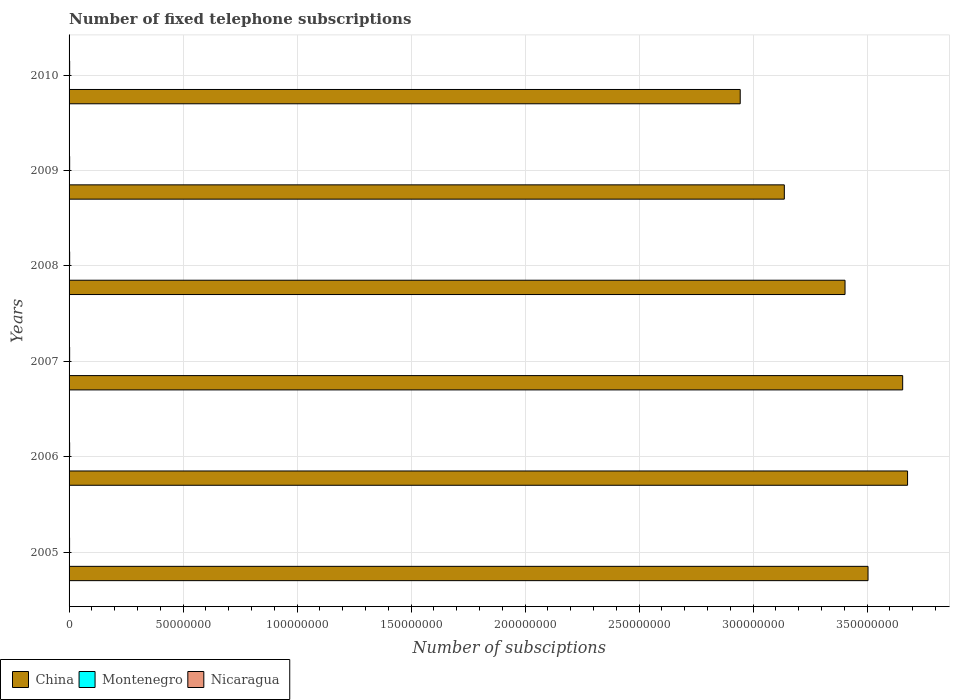How many groups of bars are there?
Ensure brevity in your answer.  6. Are the number of bars per tick equal to the number of legend labels?
Provide a succinct answer. Yes. In how many cases, is the number of bars for a given year not equal to the number of legend labels?
Make the answer very short. 0. What is the number of fixed telephone subscriptions in Montenegro in 2009?
Ensure brevity in your answer.  1.72e+05. Across all years, what is the maximum number of fixed telephone subscriptions in Montenegro?
Keep it short and to the point. 1.76e+05. Across all years, what is the minimum number of fixed telephone subscriptions in Montenegro?
Make the answer very short. 1.68e+05. In which year was the number of fixed telephone subscriptions in China minimum?
Offer a terse response. 2010. What is the total number of fixed telephone subscriptions in Montenegro in the graph?
Give a very brief answer. 1.03e+06. What is the difference between the number of fixed telephone subscriptions in Montenegro in 2007 and that in 2010?
Offer a very short reply. 5736. What is the difference between the number of fixed telephone subscriptions in Montenegro in 2010 and the number of fixed telephone subscriptions in China in 2007?
Give a very brief answer. -3.65e+08. What is the average number of fixed telephone subscriptions in Montenegro per year?
Keep it short and to the point. 1.72e+05. In the year 2008, what is the difference between the number of fixed telephone subscriptions in China and number of fixed telephone subscriptions in Montenegro?
Your response must be concise. 3.40e+08. In how many years, is the number of fixed telephone subscriptions in China greater than 10000000 ?
Provide a succinct answer. 6. What is the ratio of the number of fixed telephone subscriptions in China in 2005 to that in 2010?
Your answer should be very brief. 1.19. Is the number of fixed telephone subscriptions in Nicaragua in 2007 less than that in 2009?
Provide a short and direct response. Yes. What is the difference between the highest and the second highest number of fixed telephone subscriptions in Nicaragua?
Make the answer very short. 3639. What is the difference between the highest and the lowest number of fixed telephone subscriptions in Montenegro?
Give a very brief answer. 8056. What does the 2nd bar from the top in 2005 represents?
Make the answer very short. Montenegro. What does the 2nd bar from the bottom in 2010 represents?
Keep it short and to the point. Montenegro. How many bars are there?
Give a very brief answer. 18. What is the difference between two consecutive major ticks on the X-axis?
Your answer should be very brief. 5.00e+07. Are the values on the major ticks of X-axis written in scientific E-notation?
Your answer should be compact. No. Does the graph contain grids?
Keep it short and to the point. Yes. How many legend labels are there?
Your response must be concise. 3. How are the legend labels stacked?
Give a very brief answer. Horizontal. What is the title of the graph?
Provide a succinct answer. Number of fixed telephone subscriptions. Does "High income: OECD" appear as one of the legend labels in the graph?
Keep it short and to the point. No. What is the label or title of the X-axis?
Ensure brevity in your answer.  Number of subsciptions. What is the Number of subsciptions of China in 2005?
Give a very brief answer. 3.50e+08. What is the Number of subsciptions of Montenegro in 2005?
Ensure brevity in your answer.  1.71e+05. What is the Number of subsciptions in Nicaragua in 2005?
Make the answer very short. 2.21e+05. What is the Number of subsciptions of China in 2006?
Your answer should be very brief. 3.68e+08. What is the Number of subsciptions in Montenegro in 2006?
Make the answer very short. 1.68e+05. What is the Number of subsciptions in Nicaragua in 2006?
Your answer should be very brief. 2.48e+05. What is the Number of subsciptions in China in 2007?
Offer a terse response. 3.66e+08. What is the Number of subsciptions of Montenegro in 2007?
Ensure brevity in your answer.  1.76e+05. What is the Number of subsciptions of Nicaragua in 2007?
Offer a very short reply. 2.49e+05. What is the Number of subsciptions in China in 2008?
Your answer should be very brief. 3.40e+08. What is the Number of subsciptions of Montenegro in 2008?
Make the answer very short. 1.74e+05. What is the Number of subsciptions in Nicaragua in 2008?
Your answer should be very brief. 2.54e+05. What is the Number of subsciptions of China in 2009?
Ensure brevity in your answer.  3.14e+08. What is the Number of subsciptions in Montenegro in 2009?
Ensure brevity in your answer.  1.72e+05. What is the Number of subsciptions of Nicaragua in 2009?
Keep it short and to the point. 2.55e+05. What is the Number of subsciptions of China in 2010?
Provide a succinct answer. 2.94e+08. What is the Number of subsciptions of Montenegro in 2010?
Your answer should be very brief. 1.71e+05. What is the Number of subsciptions of Nicaragua in 2010?
Your answer should be compact. 2.58e+05. Across all years, what is the maximum Number of subsciptions of China?
Give a very brief answer. 3.68e+08. Across all years, what is the maximum Number of subsciptions in Montenegro?
Ensure brevity in your answer.  1.76e+05. Across all years, what is the maximum Number of subsciptions of Nicaragua?
Offer a terse response. 2.58e+05. Across all years, what is the minimum Number of subsciptions of China?
Make the answer very short. 2.94e+08. Across all years, what is the minimum Number of subsciptions of Montenegro?
Make the answer very short. 1.68e+05. Across all years, what is the minimum Number of subsciptions in Nicaragua?
Offer a very short reply. 2.21e+05. What is the total Number of subsciptions in China in the graph?
Make the answer very short. 2.03e+09. What is the total Number of subsciptions in Montenegro in the graph?
Make the answer very short. 1.03e+06. What is the total Number of subsciptions in Nicaragua in the graph?
Your answer should be very brief. 1.49e+06. What is the difference between the Number of subsciptions of China in 2005 and that in 2006?
Provide a succinct answer. -1.73e+07. What is the difference between the Number of subsciptions in Montenegro in 2005 and that in 2006?
Provide a short and direct response. 2700. What is the difference between the Number of subsciptions in Nicaragua in 2005 and that in 2006?
Provide a succinct answer. -2.70e+04. What is the difference between the Number of subsciptions in China in 2005 and that in 2007?
Your response must be concise. -1.52e+07. What is the difference between the Number of subsciptions of Montenegro in 2005 and that in 2007?
Offer a terse response. -5356. What is the difference between the Number of subsciptions in Nicaragua in 2005 and that in 2007?
Give a very brief answer. -2.81e+04. What is the difference between the Number of subsciptions of China in 2005 and that in 2008?
Provide a succinct answer. 1.01e+07. What is the difference between the Number of subsciptions of Montenegro in 2005 and that in 2008?
Provide a short and direct response. -3113. What is the difference between the Number of subsciptions in Nicaragua in 2005 and that in 2008?
Give a very brief answer. -3.36e+04. What is the difference between the Number of subsciptions of China in 2005 and that in 2009?
Your answer should be very brief. 3.67e+07. What is the difference between the Number of subsciptions of Montenegro in 2005 and that in 2009?
Make the answer very short. -816. What is the difference between the Number of subsciptions in Nicaragua in 2005 and that in 2009?
Provide a short and direct response. -3.38e+04. What is the difference between the Number of subsciptions in China in 2005 and that in 2010?
Offer a very short reply. 5.61e+07. What is the difference between the Number of subsciptions of Montenegro in 2005 and that in 2010?
Give a very brief answer. 380. What is the difference between the Number of subsciptions of Nicaragua in 2005 and that in 2010?
Offer a terse response. -3.75e+04. What is the difference between the Number of subsciptions of China in 2006 and that in 2007?
Ensure brevity in your answer.  2.15e+06. What is the difference between the Number of subsciptions in Montenegro in 2006 and that in 2007?
Make the answer very short. -8056. What is the difference between the Number of subsciptions of Nicaragua in 2006 and that in 2007?
Offer a very short reply. -1138. What is the difference between the Number of subsciptions in China in 2006 and that in 2008?
Provide a short and direct response. 2.74e+07. What is the difference between the Number of subsciptions in Montenegro in 2006 and that in 2008?
Give a very brief answer. -5813. What is the difference between the Number of subsciptions of Nicaragua in 2006 and that in 2008?
Offer a terse response. -6576. What is the difference between the Number of subsciptions of China in 2006 and that in 2009?
Ensure brevity in your answer.  5.41e+07. What is the difference between the Number of subsciptions in Montenegro in 2006 and that in 2009?
Provide a short and direct response. -3516. What is the difference between the Number of subsciptions of Nicaragua in 2006 and that in 2009?
Provide a succinct answer. -6824. What is the difference between the Number of subsciptions of China in 2006 and that in 2010?
Provide a succinct answer. 7.34e+07. What is the difference between the Number of subsciptions of Montenegro in 2006 and that in 2010?
Keep it short and to the point. -2320. What is the difference between the Number of subsciptions in Nicaragua in 2006 and that in 2010?
Make the answer very short. -1.05e+04. What is the difference between the Number of subsciptions in China in 2007 and that in 2008?
Make the answer very short. 2.53e+07. What is the difference between the Number of subsciptions in Montenegro in 2007 and that in 2008?
Offer a terse response. 2243. What is the difference between the Number of subsciptions in Nicaragua in 2007 and that in 2008?
Keep it short and to the point. -5438. What is the difference between the Number of subsciptions of China in 2007 and that in 2009?
Keep it short and to the point. 5.19e+07. What is the difference between the Number of subsciptions in Montenegro in 2007 and that in 2009?
Your answer should be compact. 4540. What is the difference between the Number of subsciptions of Nicaragua in 2007 and that in 2009?
Ensure brevity in your answer.  -5686. What is the difference between the Number of subsciptions of China in 2007 and that in 2010?
Provide a succinct answer. 7.13e+07. What is the difference between the Number of subsciptions in Montenegro in 2007 and that in 2010?
Your answer should be very brief. 5736. What is the difference between the Number of subsciptions in Nicaragua in 2007 and that in 2010?
Your answer should be compact. -9325. What is the difference between the Number of subsciptions in China in 2008 and that in 2009?
Offer a very short reply. 2.66e+07. What is the difference between the Number of subsciptions in Montenegro in 2008 and that in 2009?
Give a very brief answer. 2297. What is the difference between the Number of subsciptions in Nicaragua in 2008 and that in 2009?
Give a very brief answer. -248. What is the difference between the Number of subsciptions in China in 2008 and that in 2010?
Make the answer very short. 4.60e+07. What is the difference between the Number of subsciptions of Montenegro in 2008 and that in 2010?
Offer a terse response. 3493. What is the difference between the Number of subsciptions of Nicaragua in 2008 and that in 2010?
Offer a terse response. -3887. What is the difference between the Number of subsciptions of China in 2009 and that in 2010?
Your response must be concise. 1.93e+07. What is the difference between the Number of subsciptions of Montenegro in 2009 and that in 2010?
Your answer should be compact. 1196. What is the difference between the Number of subsciptions in Nicaragua in 2009 and that in 2010?
Ensure brevity in your answer.  -3639. What is the difference between the Number of subsciptions of China in 2005 and the Number of subsciptions of Montenegro in 2006?
Make the answer very short. 3.50e+08. What is the difference between the Number of subsciptions in China in 2005 and the Number of subsciptions in Nicaragua in 2006?
Make the answer very short. 3.50e+08. What is the difference between the Number of subsciptions in Montenegro in 2005 and the Number of subsciptions in Nicaragua in 2006?
Make the answer very short. -7.69e+04. What is the difference between the Number of subsciptions in China in 2005 and the Number of subsciptions in Montenegro in 2007?
Provide a short and direct response. 3.50e+08. What is the difference between the Number of subsciptions of China in 2005 and the Number of subsciptions of Nicaragua in 2007?
Your answer should be very brief. 3.50e+08. What is the difference between the Number of subsciptions in Montenegro in 2005 and the Number of subsciptions in Nicaragua in 2007?
Provide a short and direct response. -7.81e+04. What is the difference between the Number of subsciptions in China in 2005 and the Number of subsciptions in Montenegro in 2008?
Your answer should be compact. 3.50e+08. What is the difference between the Number of subsciptions in China in 2005 and the Number of subsciptions in Nicaragua in 2008?
Provide a short and direct response. 3.50e+08. What is the difference between the Number of subsciptions in Montenegro in 2005 and the Number of subsciptions in Nicaragua in 2008?
Make the answer very short. -8.35e+04. What is the difference between the Number of subsciptions of China in 2005 and the Number of subsciptions of Montenegro in 2009?
Offer a terse response. 3.50e+08. What is the difference between the Number of subsciptions of China in 2005 and the Number of subsciptions of Nicaragua in 2009?
Offer a terse response. 3.50e+08. What is the difference between the Number of subsciptions of Montenegro in 2005 and the Number of subsciptions of Nicaragua in 2009?
Make the answer very short. -8.38e+04. What is the difference between the Number of subsciptions in China in 2005 and the Number of subsciptions in Montenegro in 2010?
Ensure brevity in your answer.  3.50e+08. What is the difference between the Number of subsciptions in China in 2005 and the Number of subsciptions in Nicaragua in 2010?
Provide a succinct answer. 3.50e+08. What is the difference between the Number of subsciptions of Montenegro in 2005 and the Number of subsciptions of Nicaragua in 2010?
Make the answer very short. -8.74e+04. What is the difference between the Number of subsciptions of China in 2006 and the Number of subsciptions of Montenegro in 2007?
Ensure brevity in your answer.  3.68e+08. What is the difference between the Number of subsciptions of China in 2006 and the Number of subsciptions of Nicaragua in 2007?
Keep it short and to the point. 3.68e+08. What is the difference between the Number of subsciptions of Montenegro in 2006 and the Number of subsciptions of Nicaragua in 2007?
Your answer should be compact. -8.08e+04. What is the difference between the Number of subsciptions of China in 2006 and the Number of subsciptions of Montenegro in 2008?
Keep it short and to the point. 3.68e+08. What is the difference between the Number of subsciptions of China in 2006 and the Number of subsciptions of Nicaragua in 2008?
Ensure brevity in your answer.  3.68e+08. What is the difference between the Number of subsciptions in Montenegro in 2006 and the Number of subsciptions in Nicaragua in 2008?
Ensure brevity in your answer.  -8.62e+04. What is the difference between the Number of subsciptions of China in 2006 and the Number of subsciptions of Montenegro in 2009?
Give a very brief answer. 3.68e+08. What is the difference between the Number of subsciptions of China in 2006 and the Number of subsciptions of Nicaragua in 2009?
Offer a very short reply. 3.68e+08. What is the difference between the Number of subsciptions in Montenegro in 2006 and the Number of subsciptions in Nicaragua in 2009?
Your answer should be compact. -8.65e+04. What is the difference between the Number of subsciptions in China in 2006 and the Number of subsciptions in Montenegro in 2010?
Ensure brevity in your answer.  3.68e+08. What is the difference between the Number of subsciptions of China in 2006 and the Number of subsciptions of Nicaragua in 2010?
Keep it short and to the point. 3.68e+08. What is the difference between the Number of subsciptions of Montenegro in 2006 and the Number of subsciptions of Nicaragua in 2010?
Keep it short and to the point. -9.01e+04. What is the difference between the Number of subsciptions of China in 2007 and the Number of subsciptions of Montenegro in 2008?
Keep it short and to the point. 3.65e+08. What is the difference between the Number of subsciptions of China in 2007 and the Number of subsciptions of Nicaragua in 2008?
Give a very brief answer. 3.65e+08. What is the difference between the Number of subsciptions in Montenegro in 2007 and the Number of subsciptions in Nicaragua in 2008?
Your response must be concise. -7.81e+04. What is the difference between the Number of subsciptions in China in 2007 and the Number of subsciptions in Montenegro in 2009?
Offer a very short reply. 3.65e+08. What is the difference between the Number of subsciptions in China in 2007 and the Number of subsciptions in Nicaragua in 2009?
Offer a very short reply. 3.65e+08. What is the difference between the Number of subsciptions of Montenegro in 2007 and the Number of subsciptions of Nicaragua in 2009?
Keep it short and to the point. -7.84e+04. What is the difference between the Number of subsciptions in China in 2007 and the Number of subsciptions in Montenegro in 2010?
Offer a terse response. 3.65e+08. What is the difference between the Number of subsciptions of China in 2007 and the Number of subsciptions of Nicaragua in 2010?
Keep it short and to the point. 3.65e+08. What is the difference between the Number of subsciptions in Montenegro in 2007 and the Number of subsciptions in Nicaragua in 2010?
Offer a very short reply. -8.20e+04. What is the difference between the Number of subsciptions of China in 2008 and the Number of subsciptions of Montenegro in 2009?
Provide a short and direct response. 3.40e+08. What is the difference between the Number of subsciptions in China in 2008 and the Number of subsciptions in Nicaragua in 2009?
Your answer should be very brief. 3.40e+08. What is the difference between the Number of subsciptions of Montenegro in 2008 and the Number of subsciptions of Nicaragua in 2009?
Your response must be concise. -8.06e+04. What is the difference between the Number of subsciptions in China in 2008 and the Number of subsciptions in Montenegro in 2010?
Ensure brevity in your answer.  3.40e+08. What is the difference between the Number of subsciptions in China in 2008 and the Number of subsciptions in Nicaragua in 2010?
Offer a very short reply. 3.40e+08. What is the difference between the Number of subsciptions in Montenegro in 2008 and the Number of subsciptions in Nicaragua in 2010?
Offer a very short reply. -8.43e+04. What is the difference between the Number of subsciptions of China in 2009 and the Number of subsciptions of Montenegro in 2010?
Your response must be concise. 3.14e+08. What is the difference between the Number of subsciptions in China in 2009 and the Number of subsciptions in Nicaragua in 2010?
Keep it short and to the point. 3.13e+08. What is the difference between the Number of subsciptions in Montenegro in 2009 and the Number of subsciptions in Nicaragua in 2010?
Your response must be concise. -8.66e+04. What is the average Number of subsciptions in China per year?
Offer a very short reply. 3.39e+08. What is the average Number of subsciptions in Montenegro per year?
Provide a succinct answer. 1.72e+05. What is the average Number of subsciptions in Nicaragua per year?
Ensure brevity in your answer.  2.48e+05. In the year 2005, what is the difference between the Number of subsciptions of China and Number of subsciptions of Montenegro?
Give a very brief answer. 3.50e+08. In the year 2005, what is the difference between the Number of subsciptions of China and Number of subsciptions of Nicaragua?
Provide a succinct answer. 3.50e+08. In the year 2005, what is the difference between the Number of subsciptions of Montenegro and Number of subsciptions of Nicaragua?
Your answer should be very brief. -4.99e+04. In the year 2006, what is the difference between the Number of subsciptions in China and Number of subsciptions in Montenegro?
Ensure brevity in your answer.  3.68e+08. In the year 2006, what is the difference between the Number of subsciptions in China and Number of subsciptions in Nicaragua?
Ensure brevity in your answer.  3.68e+08. In the year 2006, what is the difference between the Number of subsciptions of Montenegro and Number of subsciptions of Nicaragua?
Your answer should be very brief. -7.96e+04. In the year 2007, what is the difference between the Number of subsciptions in China and Number of subsciptions in Montenegro?
Your answer should be very brief. 3.65e+08. In the year 2007, what is the difference between the Number of subsciptions of China and Number of subsciptions of Nicaragua?
Give a very brief answer. 3.65e+08. In the year 2007, what is the difference between the Number of subsciptions of Montenegro and Number of subsciptions of Nicaragua?
Offer a terse response. -7.27e+04. In the year 2008, what is the difference between the Number of subsciptions in China and Number of subsciptions in Montenegro?
Offer a very short reply. 3.40e+08. In the year 2008, what is the difference between the Number of subsciptions in China and Number of subsciptions in Nicaragua?
Your answer should be very brief. 3.40e+08. In the year 2008, what is the difference between the Number of subsciptions of Montenegro and Number of subsciptions of Nicaragua?
Give a very brief answer. -8.04e+04. In the year 2009, what is the difference between the Number of subsciptions of China and Number of subsciptions of Montenegro?
Provide a succinct answer. 3.14e+08. In the year 2009, what is the difference between the Number of subsciptions of China and Number of subsciptions of Nicaragua?
Your response must be concise. 3.13e+08. In the year 2009, what is the difference between the Number of subsciptions of Montenegro and Number of subsciptions of Nicaragua?
Your answer should be compact. -8.29e+04. In the year 2010, what is the difference between the Number of subsciptions of China and Number of subsciptions of Montenegro?
Your response must be concise. 2.94e+08. In the year 2010, what is the difference between the Number of subsciptions of China and Number of subsciptions of Nicaragua?
Your response must be concise. 2.94e+08. In the year 2010, what is the difference between the Number of subsciptions of Montenegro and Number of subsciptions of Nicaragua?
Ensure brevity in your answer.  -8.78e+04. What is the ratio of the Number of subsciptions of China in 2005 to that in 2006?
Keep it short and to the point. 0.95. What is the ratio of the Number of subsciptions of Nicaragua in 2005 to that in 2006?
Provide a succinct answer. 0.89. What is the ratio of the Number of subsciptions in China in 2005 to that in 2007?
Provide a short and direct response. 0.96. What is the ratio of the Number of subsciptions of Montenegro in 2005 to that in 2007?
Give a very brief answer. 0.97. What is the ratio of the Number of subsciptions in Nicaragua in 2005 to that in 2007?
Provide a succinct answer. 0.89. What is the ratio of the Number of subsciptions of China in 2005 to that in 2008?
Offer a terse response. 1.03. What is the ratio of the Number of subsciptions of Montenegro in 2005 to that in 2008?
Keep it short and to the point. 0.98. What is the ratio of the Number of subsciptions of Nicaragua in 2005 to that in 2008?
Your answer should be compact. 0.87. What is the ratio of the Number of subsciptions in China in 2005 to that in 2009?
Your response must be concise. 1.12. What is the ratio of the Number of subsciptions of Nicaragua in 2005 to that in 2009?
Give a very brief answer. 0.87. What is the ratio of the Number of subsciptions in China in 2005 to that in 2010?
Offer a very short reply. 1.19. What is the ratio of the Number of subsciptions in Nicaragua in 2005 to that in 2010?
Ensure brevity in your answer.  0.85. What is the ratio of the Number of subsciptions of China in 2006 to that in 2007?
Your answer should be compact. 1.01. What is the ratio of the Number of subsciptions of Montenegro in 2006 to that in 2007?
Offer a terse response. 0.95. What is the ratio of the Number of subsciptions of China in 2006 to that in 2008?
Your answer should be compact. 1.08. What is the ratio of the Number of subsciptions in Montenegro in 2006 to that in 2008?
Your response must be concise. 0.97. What is the ratio of the Number of subsciptions in Nicaragua in 2006 to that in 2008?
Your answer should be very brief. 0.97. What is the ratio of the Number of subsciptions of China in 2006 to that in 2009?
Provide a short and direct response. 1.17. What is the ratio of the Number of subsciptions of Montenegro in 2006 to that in 2009?
Provide a succinct answer. 0.98. What is the ratio of the Number of subsciptions of Nicaragua in 2006 to that in 2009?
Provide a succinct answer. 0.97. What is the ratio of the Number of subsciptions in China in 2006 to that in 2010?
Your response must be concise. 1.25. What is the ratio of the Number of subsciptions in Montenegro in 2006 to that in 2010?
Your response must be concise. 0.99. What is the ratio of the Number of subsciptions of Nicaragua in 2006 to that in 2010?
Give a very brief answer. 0.96. What is the ratio of the Number of subsciptions in China in 2007 to that in 2008?
Ensure brevity in your answer.  1.07. What is the ratio of the Number of subsciptions in Montenegro in 2007 to that in 2008?
Provide a succinct answer. 1.01. What is the ratio of the Number of subsciptions in Nicaragua in 2007 to that in 2008?
Ensure brevity in your answer.  0.98. What is the ratio of the Number of subsciptions of China in 2007 to that in 2009?
Offer a terse response. 1.17. What is the ratio of the Number of subsciptions in Montenegro in 2007 to that in 2009?
Give a very brief answer. 1.03. What is the ratio of the Number of subsciptions in Nicaragua in 2007 to that in 2009?
Provide a succinct answer. 0.98. What is the ratio of the Number of subsciptions of China in 2007 to that in 2010?
Offer a very short reply. 1.24. What is the ratio of the Number of subsciptions in Montenegro in 2007 to that in 2010?
Your answer should be very brief. 1.03. What is the ratio of the Number of subsciptions of Nicaragua in 2007 to that in 2010?
Your answer should be compact. 0.96. What is the ratio of the Number of subsciptions of China in 2008 to that in 2009?
Provide a succinct answer. 1.08. What is the ratio of the Number of subsciptions of Montenegro in 2008 to that in 2009?
Provide a succinct answer. 1.01. What is the ratio of the Number of subsciptions in China in 2008 to that in 2010?
Offer a very short reply. 1.16. What is the ratio of the Number of subsciptions of Montenegro in 2008 to that in 2010?
Provide a succinct answer. 1.02. What is the ratio of the Number of subsciptions in Nicaragua in 2008 to that in 2010?
Offer a very short reply. 0.98. What is the ratio of the Number of subsciptions of China in 2009 to that in 2010?
Offer a very short reply. 1.07. What is the ratio of the Number of subsciptions in Nicaragua in 2009 to that in 2010?
Offer a terse response. 0.99. What is the difference between the highest and the second highest Number of subsciptions of China?
Make the answer very short. 2.15e+06. What is the difference between the highest and the second highest Number of subsciptions of Montenegro?
Ensure brevity in your answer.  2243. What is the difference between the highest and the second highest Number of subsciptions of Nicaragua?
Ensure brevity in your answer.  3639. What is the difference between the highest and the lowest Number of subsciptions in China?
Give a very brief answer. 7.34e+07. What is the difference between the highest and the lowest Number of subsciptions in Montenegro?
Your answer should be compact. 8056. What is the difference between the highest and the lowest Number of subsciptions of Nicaragua?
Provide a short and direct response. 3.75e+04. 